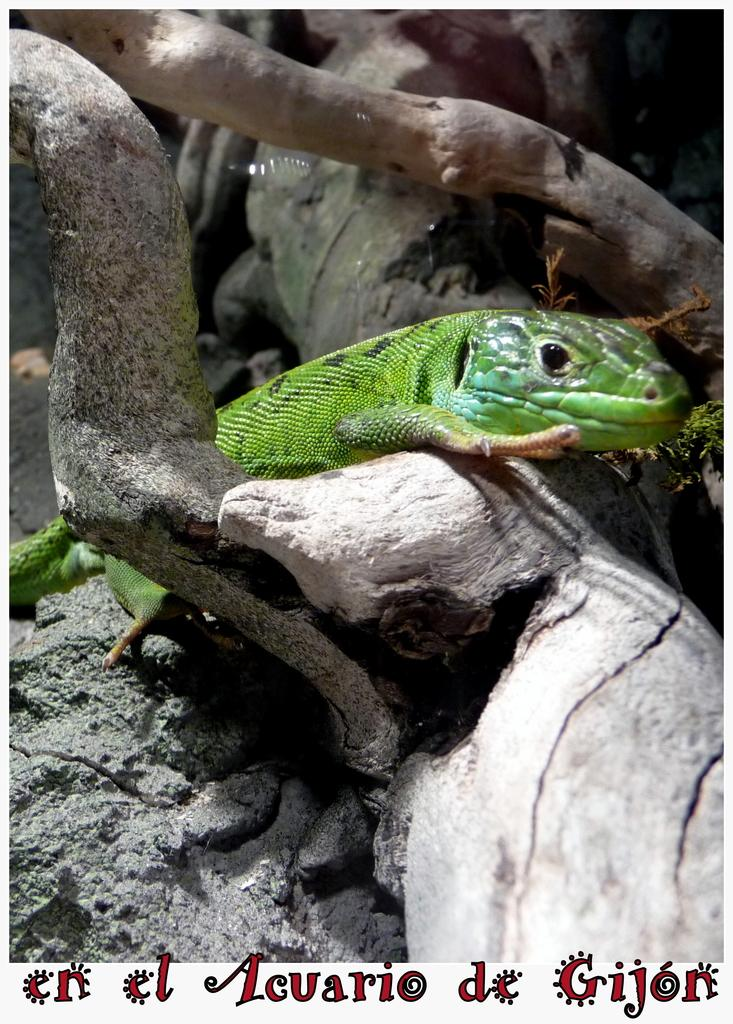What type of animal is in the image? There is a green colored lizard in the image. How is the lizard positioned in the image? The lizard is between sticks. Is there any text present in the image? Yes, there is some text at the bottom of the image. How does the lizard help with learning in the image? The image does not depict the lizard helping with learning; it simply shows a lizard between sticks. What type of transport is used by the lizard in the image? The lizard is not using any form of transport in the image; it is stationary between sticks. 